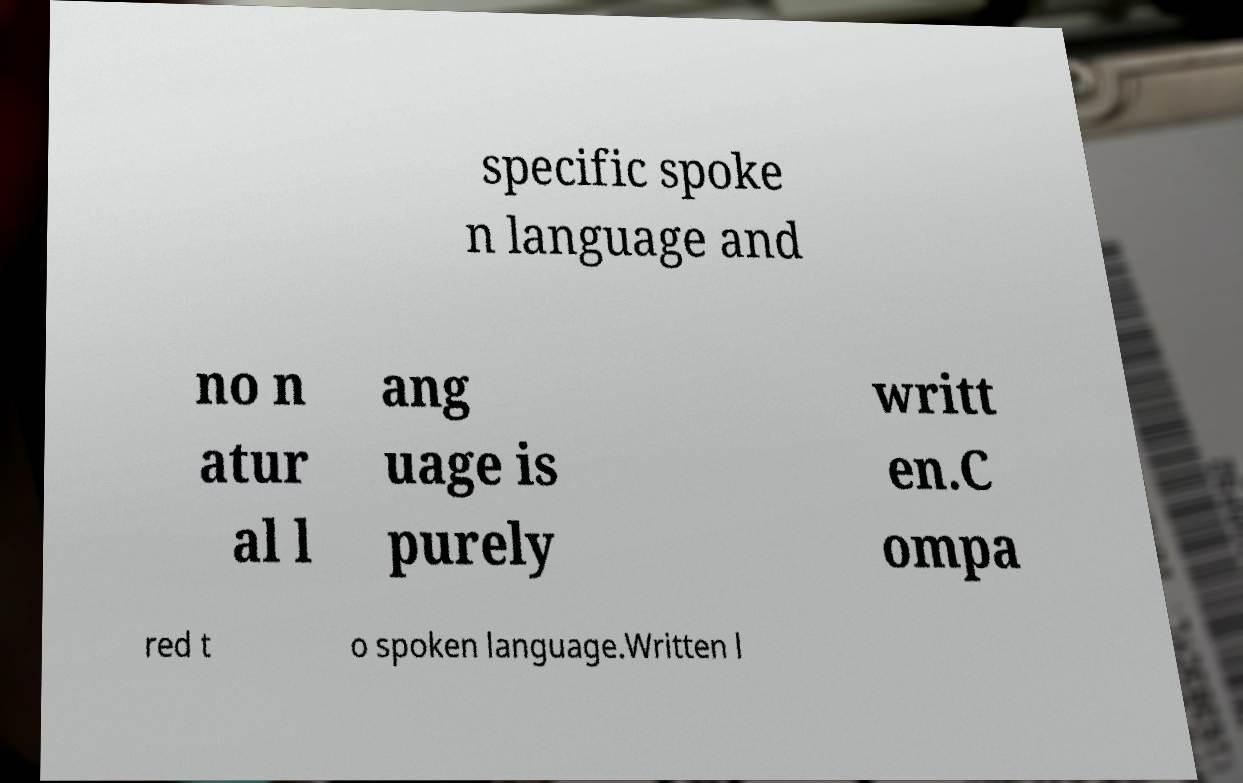Can you accurately transcribe the text from the provided image for me? specific spoke n language and no n atur al l ang uage is purely writt en.C ompa red t o spoken language.Written l 